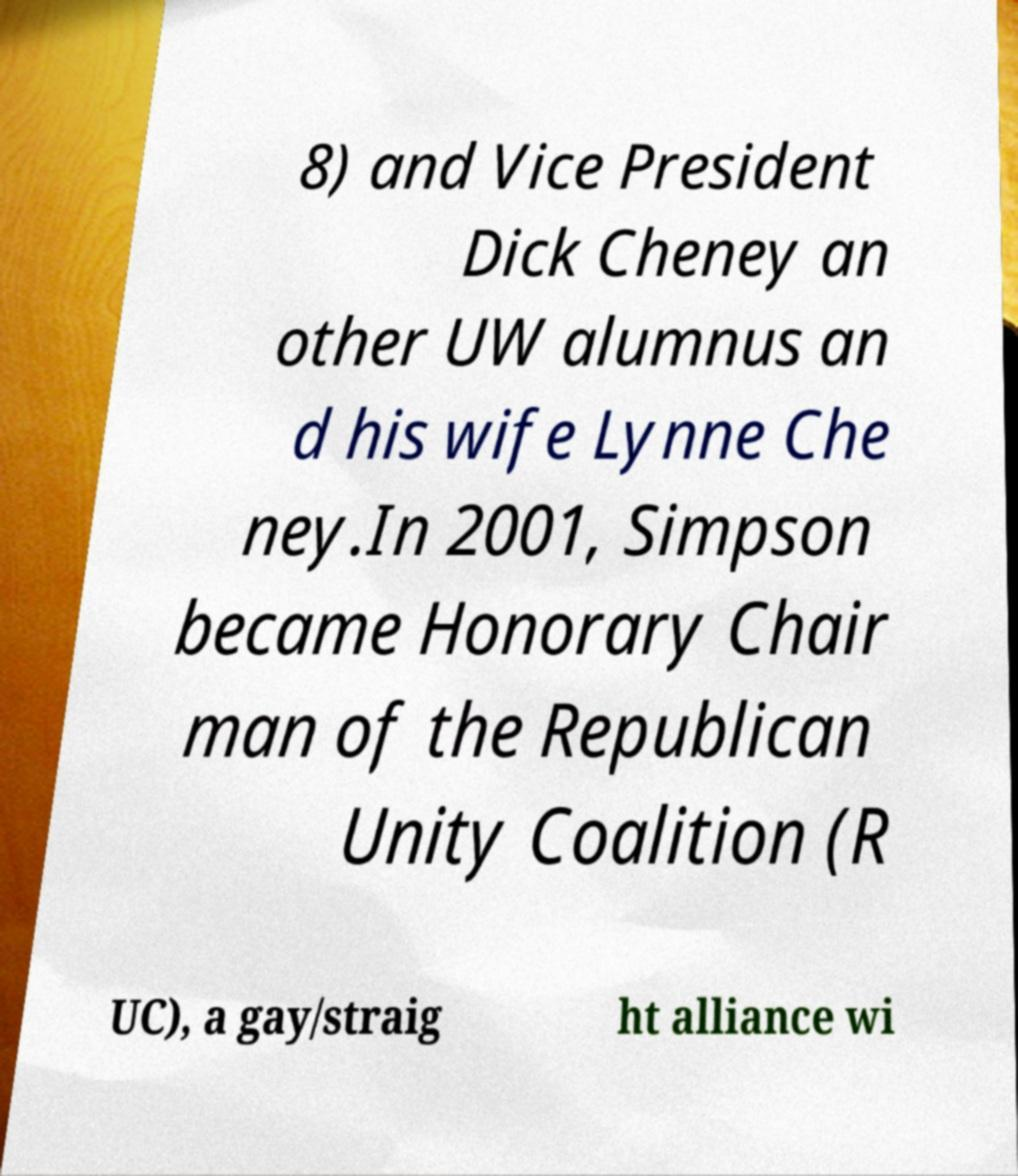Could you assist in decoding the text presented in this image and type it out clearly? 8) and Vice President Dick Cheney an other UW alumnus an d his wife Lynne Che ney.In 2001, Simpson became Honorary Chair man of the Republican Unity Coalition (R UC), a gay/straig ht alliance wi 